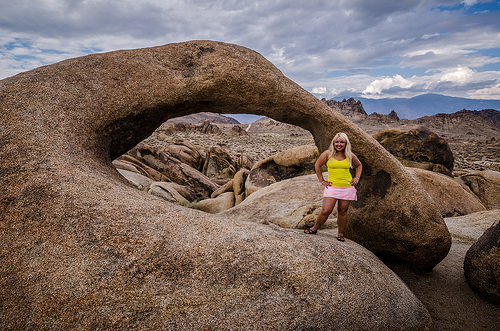<image>
Can you confirm if the woman is on the rock? Yes. Looking at the image, I can see the woman is positioned on top of the rock, with the rock providing support. 